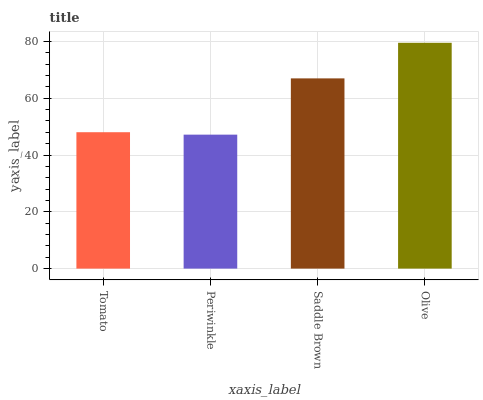Is Periwinkle the minimum?
Answer yes or no. Yes. Is Olive the maximum?
Answer yes or no. Yes. Is Saddle Brown the minimum?
Answer yes or no. No. Is Saddle Brown the maximum?
Answer yes or no. No. Is Saddle Brown greater than Periwinkle?
Answer yes or no. Yes. Is Periwinkle less than Saddle Brown?
Answer yes or no. Yes. Is Periwinkle greater than Saddle Brown?
Answer yes or no. No. Is Saddle Brown less than Periwinkle?
Answer yes or no. No. Is Saddle Brown the high median?
Answer yes or no. Yes. Is Tomato the low median?
Answer yes or no. Yes. Is Olive the high median?
Answer yes or no. No. Is Saddle Brown the low median?
Answer yes or no. No. 